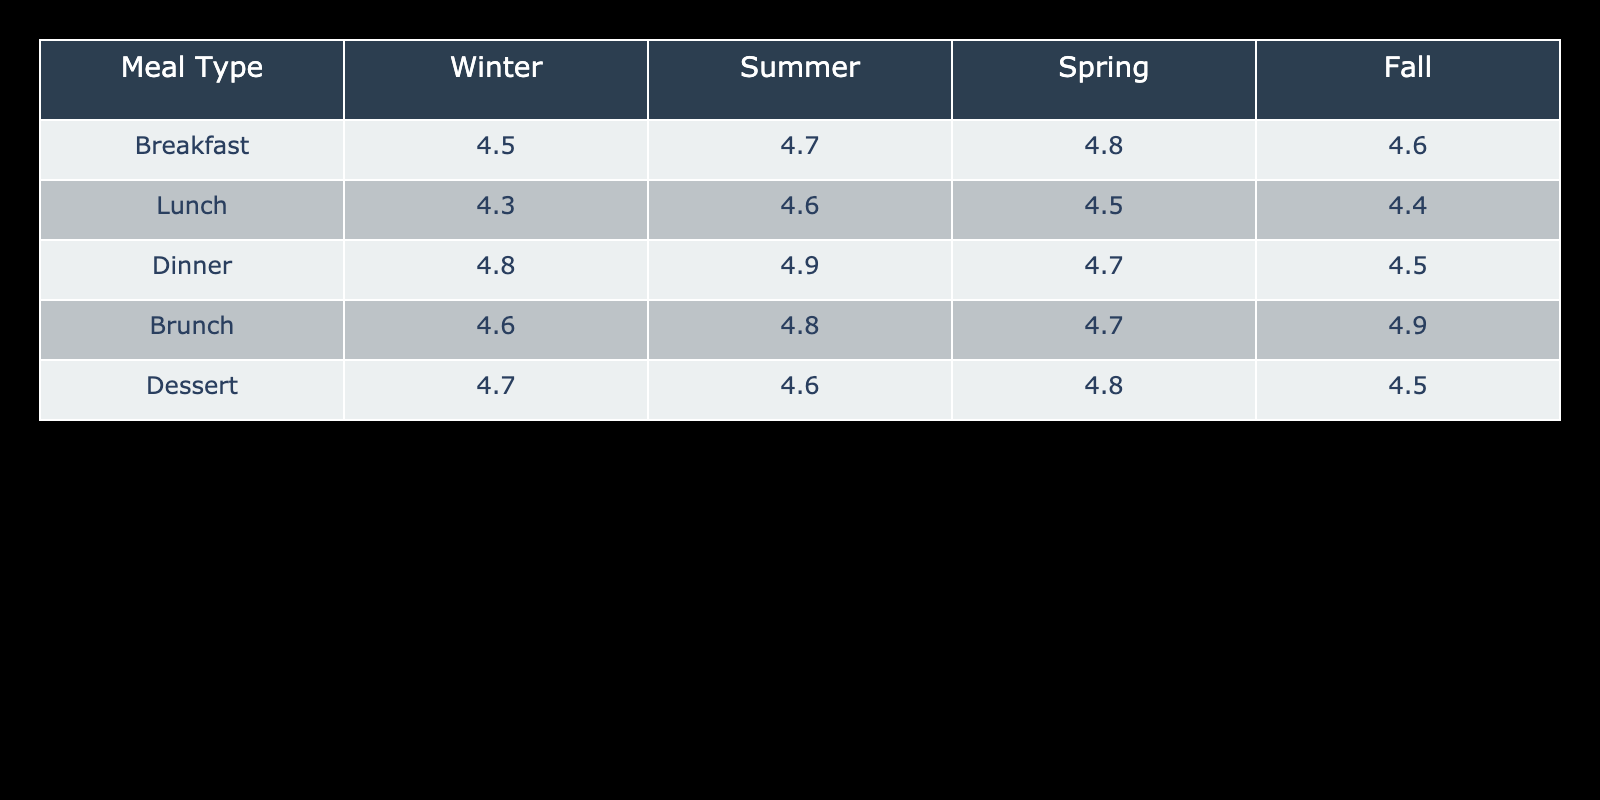What is the customer satisfaction rating for lunch in summer? Referring to the table, the customer satisfaction rating for lunch in summer is specifically listed in the summer column under the lunch row. The value is 4.6.
Answer: 4.6 Which meal type has the highest customer satisfaction rating in winter? Looking at the winter column, we can compare the ratings for each meal type: Breakfast (4.5), Lunch (4.3), Dinner (4.8), Brunch (4.6), and Dessert (4.7). The highest value is 4.8 for Dinner.
Answer: Dinner What is the average customer satisfaction rating across all meal types for spring? We need to find the ratings for each meal type in spring: Breakfast (4.8), Lunch (4.5), Dinner (4.7), Brunch (4.7), and Dessert (4.8). Adding these together gives us 4.8 + 4.5 + 4.7 + 4.7 + 4.8 = 24.5. There are 5 meal types, so we divide 24.5 by 5 to get an average of 4.9.
Answer: 4.9 Is the customer satisfaction rating for brunch higher in winter than in summer? Referring to the brunch ratings: in winter it is 4.6 and in summer it is 4.8. Since 4.6 is not higher than 4.8, the statement is false.
Answer: No Which season had the highest customer satisfaction rating for dessert? Checking the dessert ratings across the seasons: Winter (4.7), Summer (4.6), Spring (4.8), Fall (4.5). The highest rating is in Spring with a value of 4.8.
Answer: Spring What is the difference in customer satisfaction between breakfast and lunch in fall? The ratings for breakfast and lunch in fall are: Breakfast (4.6) and Lunch (4.4). The difference is calculated by subtracting the lunch rating from the breakfast rating: 4.6 - 4.4 = 0.2.
Answer: 0.2 Do customer satisfaction ratings for dinners consistently exceed 4.7 across all seasons? Evaluating the dinner ratings: Winter (4.8), Summer (4.9), Spring (4.7), Fall (4.5). The rating in Fall (4.5) is below 4.7, so the statement is false.
Answer: No Which meal type shows the most variation in customer satisfaction ratings across the seasons? Comparing the ratings across seasons, we see Breakfast (4.5 to 4.8), Lunch (4.3 to 4.6), Dinner (4.5 to 4.9), Brunch (4.6 to 4.9), and Dessert (4.5 to 4.8). The difference is greatest for Dinner, which has a range of 0.4 (4.9 - 4.5).
Answer: Dinner 